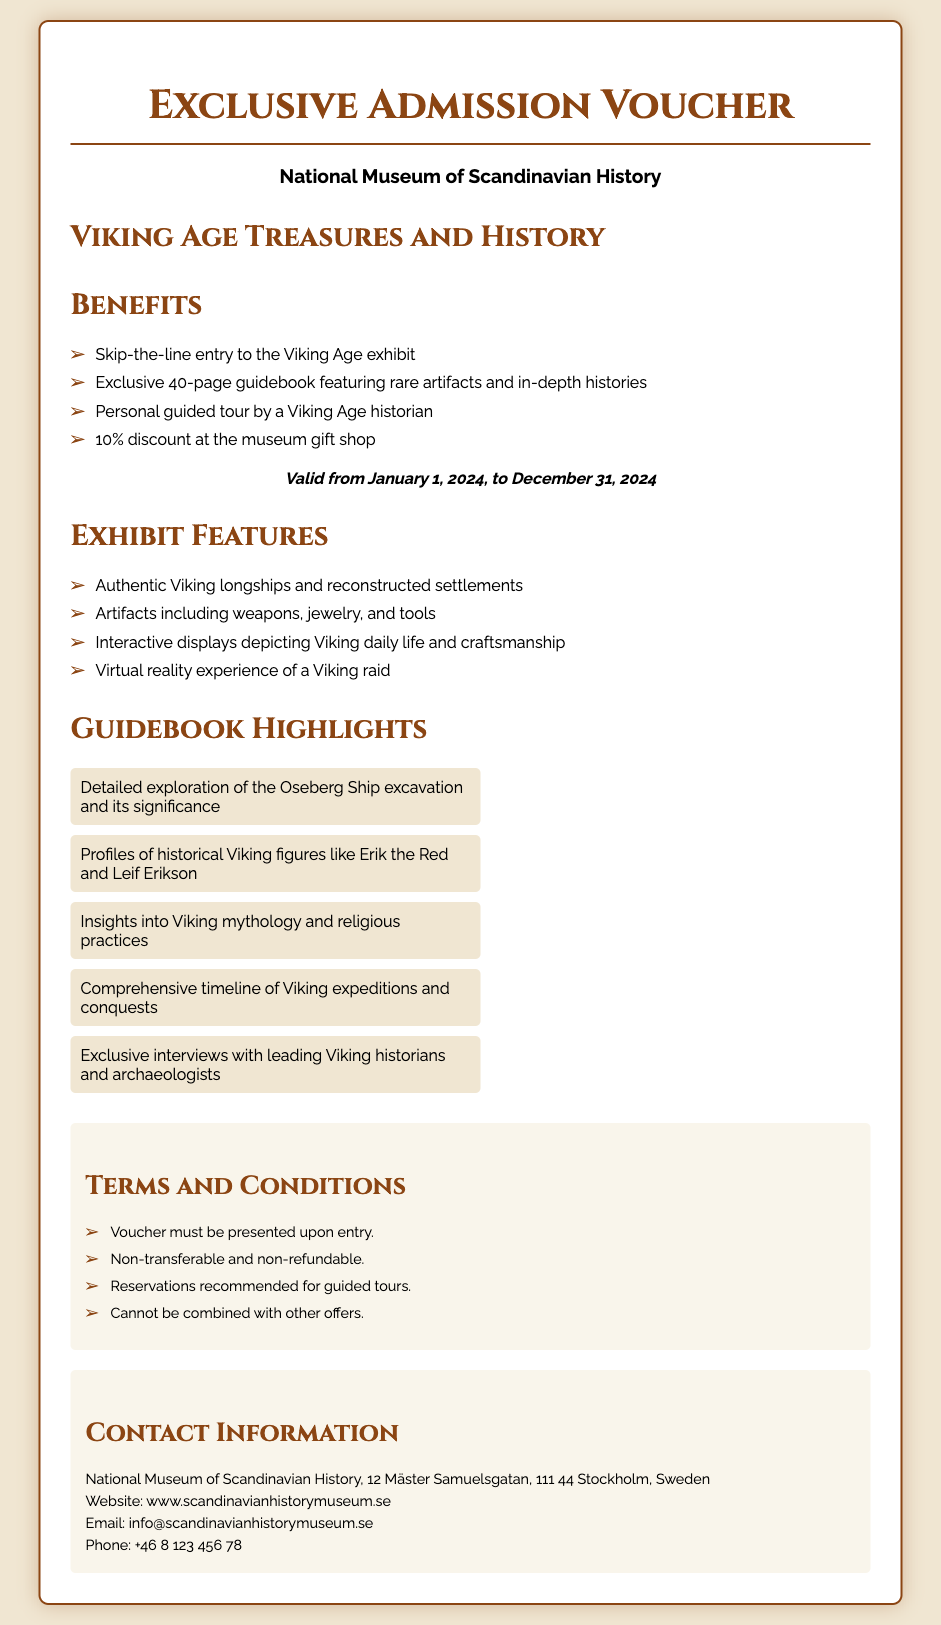What is the name of the museum? The museum's name is explicitly mentioned at the top of the voucher as the National Museum of Scandinavian History.
Answer: National Museum of Scandinavian History What is the validity period of the voucher? The validity period is clearly stated in the document, which indicates it is from January 1, 2024, to December 31, 2024.
Answer: January 1, 2024, to December 31, 2024 How many pages is the exclusive guidebook? The document specifies that the guidebook is exclusive and contains 40 pages.
Answer: 40 pages What discount does the voucher provide at the gift shop? The voucher highlights a specific discount rate at the museum gift shop, which is 10%.
Answer: 10% What is one feature of the Viking Age exhibit? The document lists various features of the exhibit, one of which is authentic Viking longships and reconstructed settlements.
Answer: Authentic Viking longships and reconstructed settlements Which historical figures are profiled in the guidebook? The guidebook includes profiles of significant historical Viking figures such as Erik the Red and Leif Erikson.
Answer: Erik the Red and Leif Erikson What are the terms of voucher transferability? The terms explicitly state that the voucher is non-transferable and non-refundable.
Answer: Non-transferable and non-refundable What is the email address for the museum? The email contact for the museum is provided in the document, which is info@scandinavianhistorymuseum.se.
Answer: info@scandinavianhistorymuseum.se What recommendation is made regarding guided tours? The terms section advises that reservations are recommended for guided tours.
Answer: Reservations recommended 